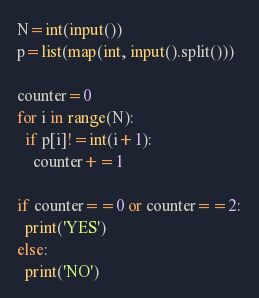<code> <loc_0><loc_0><loc_500><loc_500><_Python_>N=int(input())
p=list(map(int, input().split()))

counter=0
for i in range(N):
  if p[i]!=int(i+1):
    counter+=1
    
if counter==0 or counter==2:
  print('YES')
else:
  print('NO')</code> 